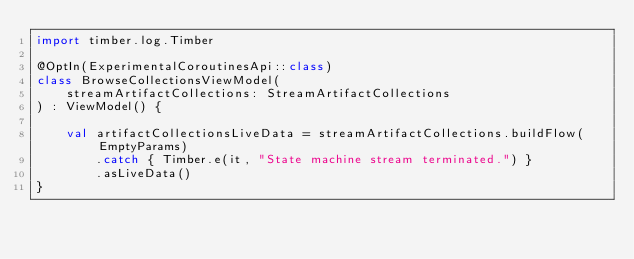<code> <loc_0><loc_0><loc_500><loc_500><_Kotlin_>import timber.log.Timber

@OptIn(ExperimentalCoroutinesApi::class)
class BrowseCollectionsViewModel(
    streamArtifactCollections: StreamArtifactCollections
) : ViewModel() {

    val artifactCollectionsLiveData = streamArtifactCollections.buildFlow(EmptyParams)
        .catch { Timber.e(it, "State machine stream terminated.") }
        .asLiveData()
}
</code> 